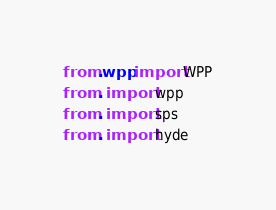Convert code to text. <code><loc_0><loc_0><loc_500><loc_500><_Python_>
from .wpp import WPP
from . import wpp
from . import sps
from . import hyde  
</code> 